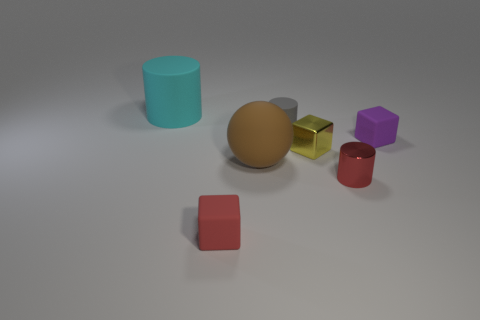Add 1 small green spheres. How many objects exist? 8 Subtract all cubes. How many objects are left? 4 Add 6 big brown things. How many big brown things exist? 7 Subtract 0 brown cubes. How many objects are left? 7 Subtract all cyan things. Subtract all brown matte spheres. How many objects are left? 5 Add 5 small red cylinders. How many small red cylinders are left? 6 